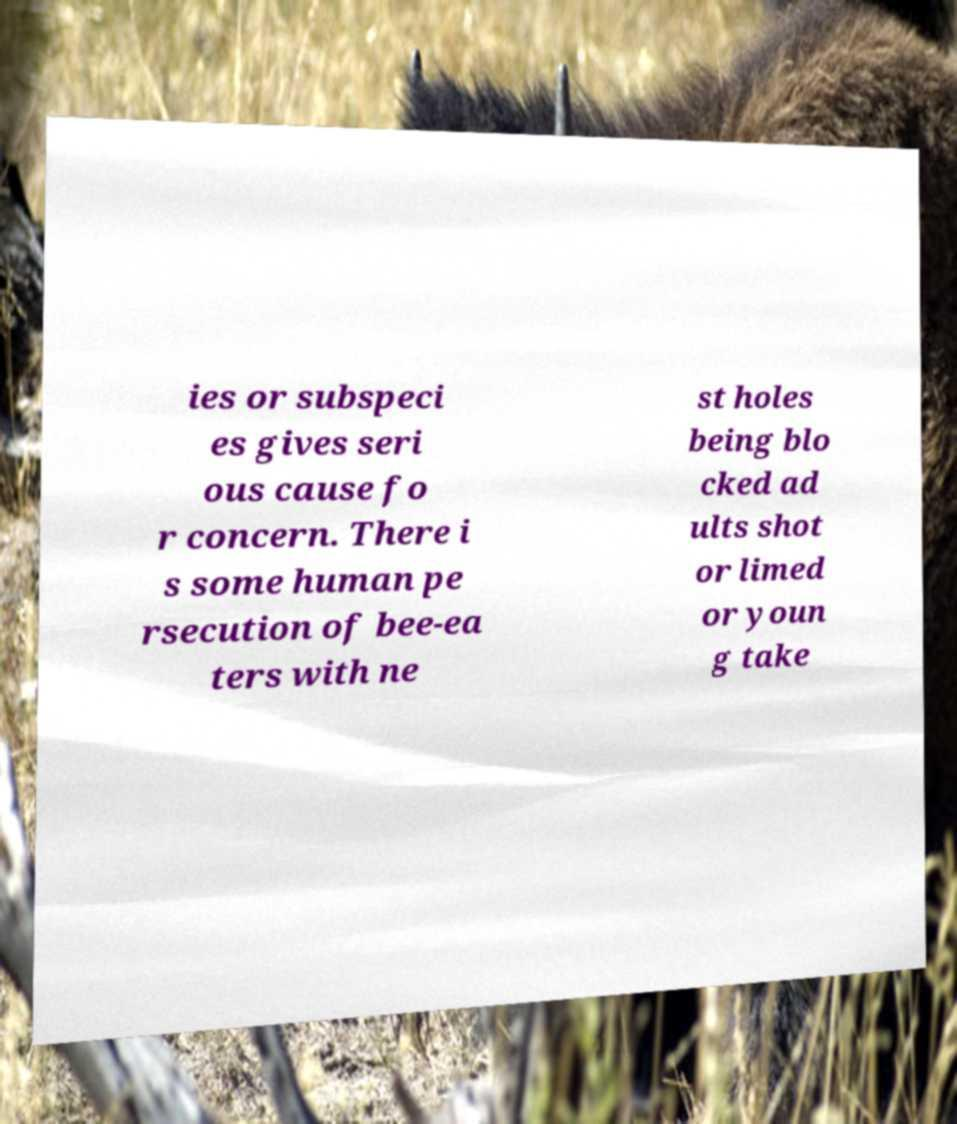What messages or text are displayed in this image? I need them in a readable, typed format. ies or subspeci es gives seri ous cause fo r concern. There i s some human pe rsecution of bee-ea ters with ne st holes being blo cked ad ults shot or limed or youn g take 